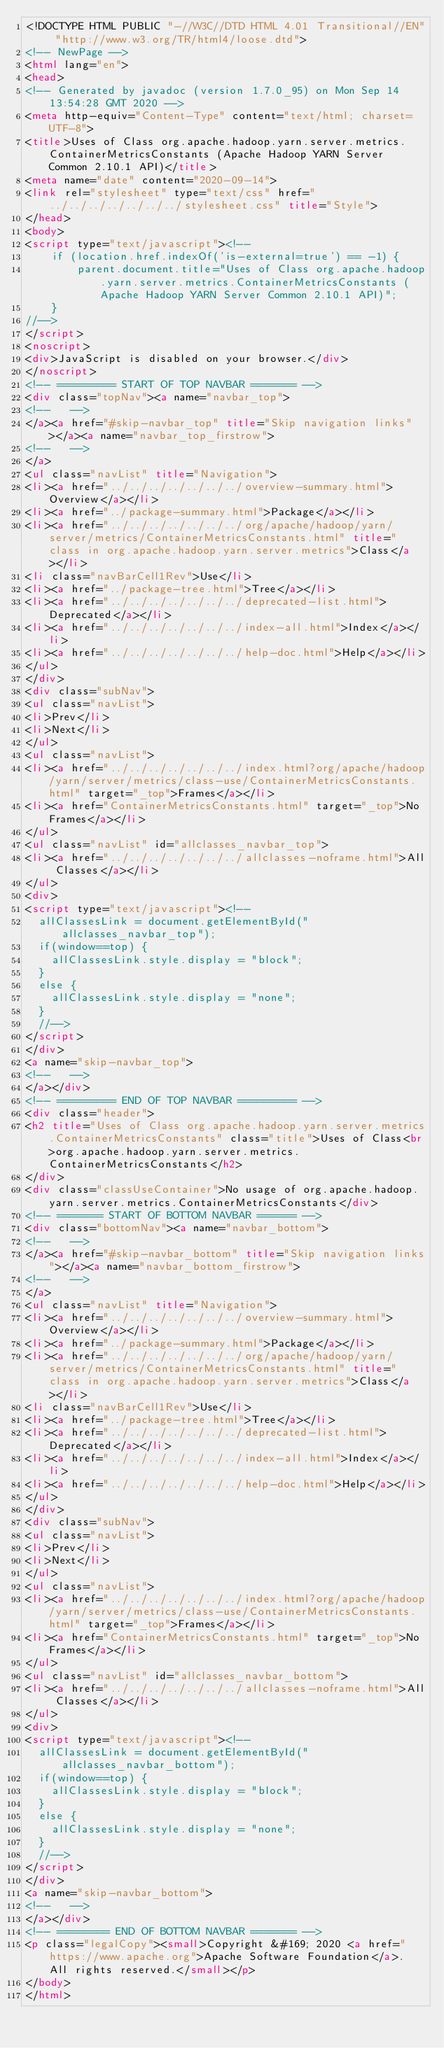Convert code to text. <code><loc_0><loc_0><loc_500><loc_500><_HTML_><!DOCTYPE HTML PUBLIC "-//W3C//DTD HTML 4.01 Transitional//EN" "http://www.w3.org/TR/html4/loose.dtd">
<!-- NewPage -->
<html lang="en">
<head>
<!-- Generated by javadoc (version 1.7.0_95) on Mon Sep 14 13:54:28 GMT 2020 -->
<meta http-equiv="Content-Type" content="text/html; charset=UTF-8">
<title>Uses of Class org.apache.hadoop.yarn.server.metrics.ContainerMetricsConstants (Apache Hadoop YARN Server Common 2.10.1 API)</title>
<meta name="date" content="2020-09-14">
<link rel="stylesheet" type="text/css" href="../../../../../../../stylesheet.css" title="Style">
</head>
<body>
<script type="text/javascript"><!--
    if (location.href.indexOf('is-external=true') == -1) {
        parent.document.title="Uses of Class org.apache.hadoop.yarn.server.metrics.ContainerMetricsConstants (Apache Hadoop YARN Server Common 2.10.1 API)";
    }
//-->
</script>
<noscript>
<div>JavaScript is disabled on your browser.</div>
</noscript>
<!-- ========= START OF TOP NAVBAR ======= -->
<div class="topNav"><a name="navbar_top">
<!--   -->
</a><a href="#skip-navbar_top" title="Skip navigation links"></a><a name="navbar_top_firstrow">
<!--   -->
</a>
<ul class="navList" title="Navigation">
<li><a href="../../../../../../../overview-summary.html">Overview</a></li>
<li><a href="../package-summary.html">Package</a></li>
<li><a href="../../../../../../../org/apache/hadoop/yarn/server/metrics/ContainerMetricsConstants.html" title="class in org.apache.hadoop.yarn.server.metrics">Class</a></li>
<li class="navBarCell1Rev">Use</li>
<li><a href="../package-tree.html">Tree</a></li>
<li><a href="../../../../../../../deprecated-list.html">Deprecated</a></li>
<li><a href="../../../../../../../index-all.html">Index</a></li>
<li><a href="../../../../../../../help-doc.html">Help</a></li>
</ul>
</div>
<div class="subNav">
<ul class="navList">
<li>Prev</li>
<li>Next</li>
</ul>
<ul class="navList">
<li><a href="../../../../../../../index.html?org/apache/hadoop/yarn/server/metrics/class-use/ContainerMetricsConstants.html" target="_top">Frames</a></li>
<li><a href="ContainerMetricsConstants.html" target="_top">No Frames</a></li>
</ul>
<ul class="navList" id="allclasses_navbar_top">
<li><a href="../../../../../../../allclasses-noframe.html">All Classes</a></li>
</ul>
<div>
<script type="text/javascript"><!--
  allClassesLink = document.getElementById("allclasses_navbar_top");
  if(window==top) {
    allClassesLink.style.display = "block";
  }
  else {
    allClassesLink.style.display = "none";
  }
  //-->
</script>
</div>
<a name="skip-navbar_top">
<!--   -->
</a></div>
<!-- ========= END OF TOP NAVBAR ========= -->
<div class="header">
<h2 title="Uses of Class org.apache.hadoop.yarn.server.metrics.ContainerMetricsConstants" class="title">Uses of Class<br>org.apache.hadoop.yarn.server.metrics.ContainerMetricsConstants</h2>
</div>
<div class="classUseContainer">No usage of org.apache.hadoop.yarn.server.metrics.ContainerMetricsConstants</div>
<!-- ======= START OF BOTTOM NAVBAR ====== -->
<div class="bottomNav"><a name="navbar_bottom">
<!--   -->
</a><a href="#skip-navbar_bottom" title="Skip navigation links"></a><a name="navbar_bottom_firstrow">
<!--   -->
</a>
<ul class="navList" title="Navigation">
<li><a href="../../../../../../../overview-summary.html">Overview</a></li>
<li><a href="../package-summary.html">Package</a></li>
<li><a href="../../../../../../../org/apache/hadoop/yarn/server/metrics/ContainerMetricsConstants.html" title="class in org.apache.hadoop.yarn.server.metrics">Class</a></li>
<li class="navBarCell1Rev">Use</li>
<li><a href="../package-tree.html">Tree</a></li>
<li><a href="../../../../../../../deprecated-list.html">Deprecated</a></li>
<li><a href="../../../../../../../index-all.html">Index</a></li>
<li><a href="../../../../../../../help-doc.html">Help</a></li>
</ul>
</div>
<div class="subNav">
<ul class="navList">
<li>Prev</li>
<li>Next</li>
</ul>
<ul class="navList">
<li><a href="../../../../../../../index.html?org/apache/hadoop/yarn/server/metrics/class-use/ContainerMetricsConstants.html" target="_top">Frames</a></li>
<li><a href="ContainerMetricsConstants.html" target="_top">No Frames</a></li>
</ul>
<ul class="navList" id="allclasses_navbar_bottom">
<li><a href="../../../../../../../allclasses-noframe.html">All Classes</a></li>
</ul>
<div>
<script type="text/javascript"><!--
  allClassesLink = document.getElementById("allclasses_navbar_bottom");
  if(window==top) {
    allClassesLink.style.display = "block";
  }
  else {
    allClassesLink.style.display = "none";
  }
  //-->
</script>
</div>
<a name="skip-navbar_bottom">
<!--   -->
</a></div>
<!-- ======== END OF BOTTOM NAVBAR ======= -->
<p class="legalCopy"><small>Copyright &#169; 2020 <a href="https://www.apache.org">Apache Software Foundation</a>. All rights reserved.</small></p>
</body>
</html>
</code> 